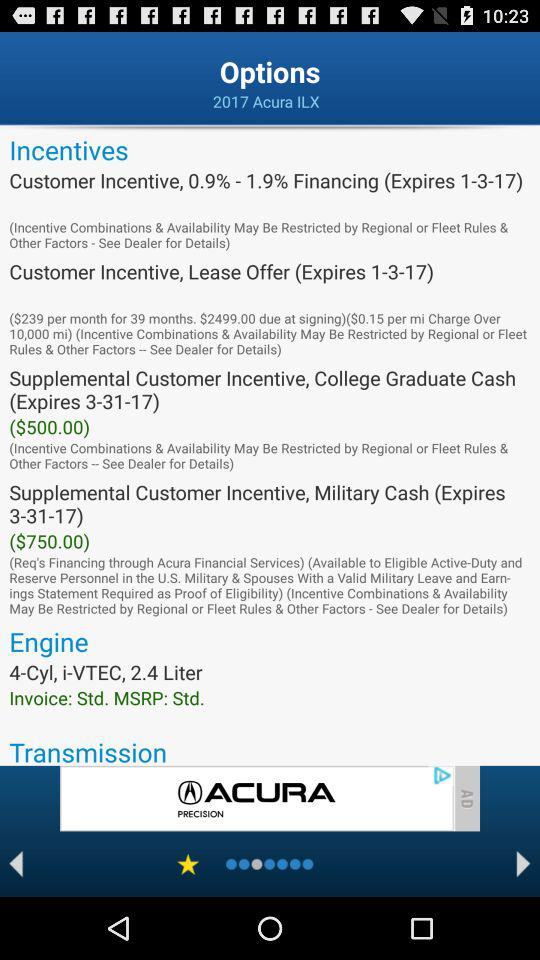Which option is selected?
When the provided information is insufficient, respond with <no answer>. <no answer> 